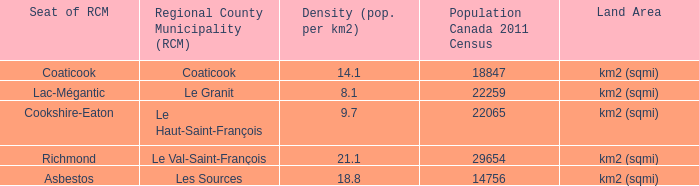What is the land area for the RCM that has a population of 18847? Km2 (sqmi). 